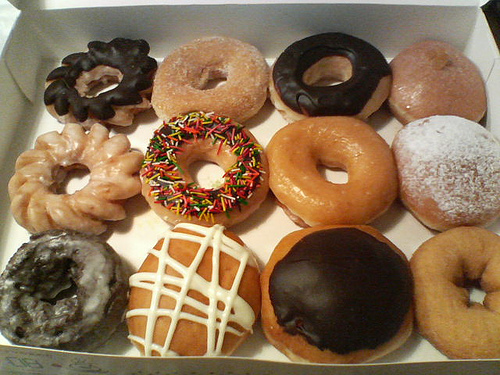Are these doughnuts suitable for someone with a nut allergy? It's difficult to determine the ingredients from the image alone. While none of the doughnuts show visible nuts, it's important for someone with a nut allergy to check with the provider for cross-contamination risks and ingredient lists. 